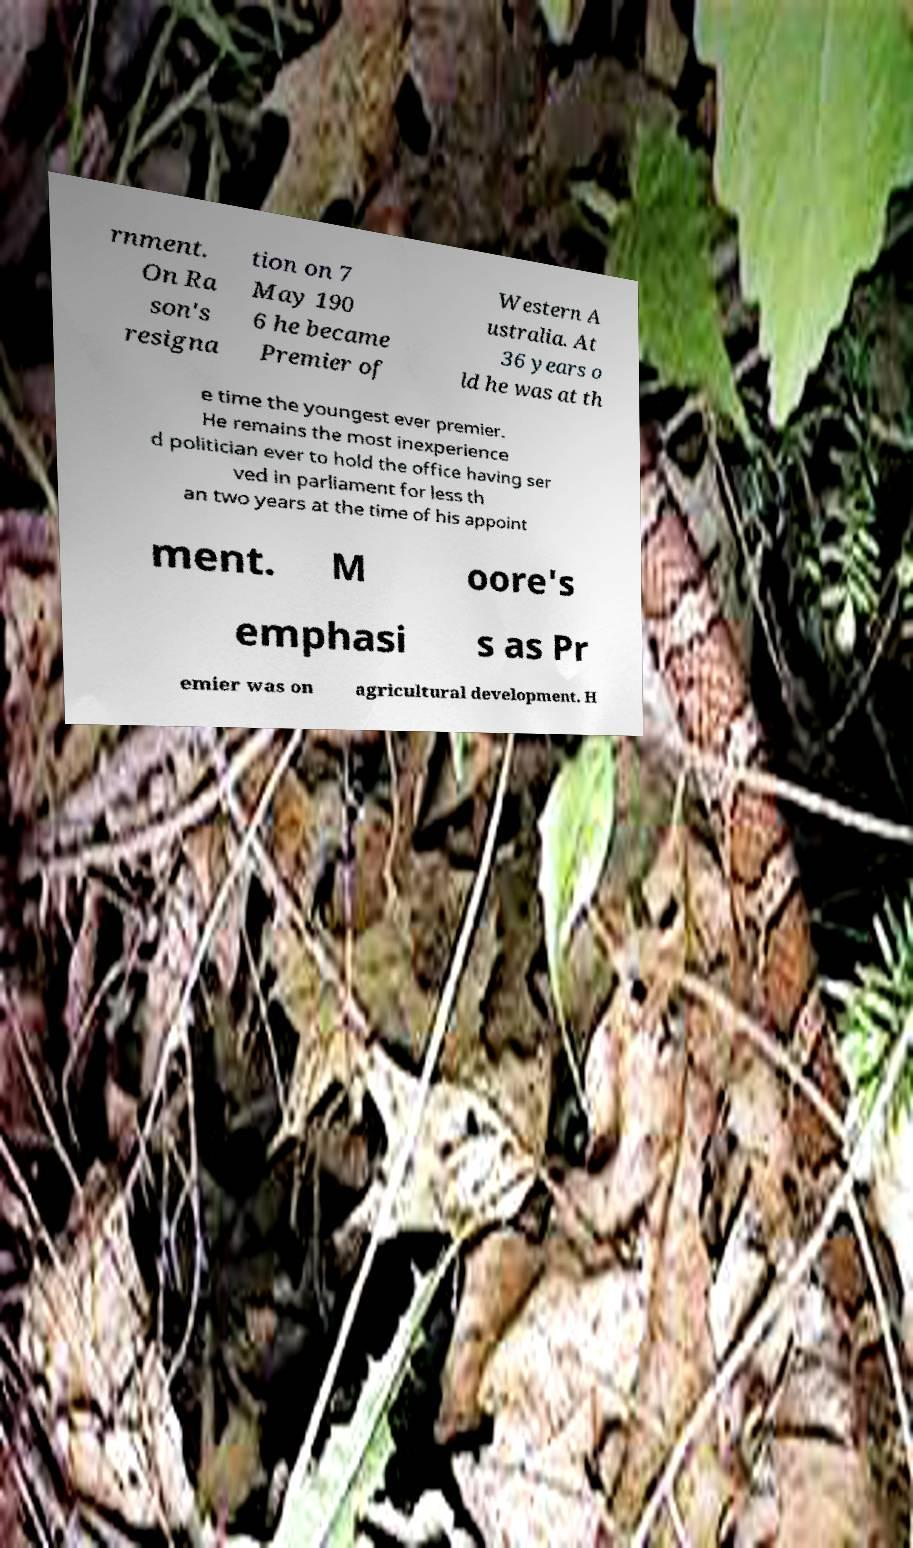Can you read and provide the text displayed in the image?This photo seems to have some interesting text. Can you extract and type it out for me? rnment. On Ra son's resigna tion on 7 May 190 6 he became Premier of Western A ustralia. At 36 years o ld he was at th e time the youngest ever premier. He remains the most inexperience d politician ever to hold the office having ser ved in parliament for less th an two years at the time of his appoint ment. M oore's emphasi s as Pr emier was on agricultural development. H 